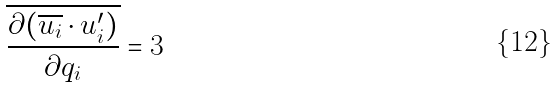<formula> <loc_0><loc_0><loc_500><loc_500>\overline { \frac { \partial ( \overline { u _ { i } } \cdot u _ { i } ^ { \prime } ) } { \partial q _ { i } } } = 3</formula> 